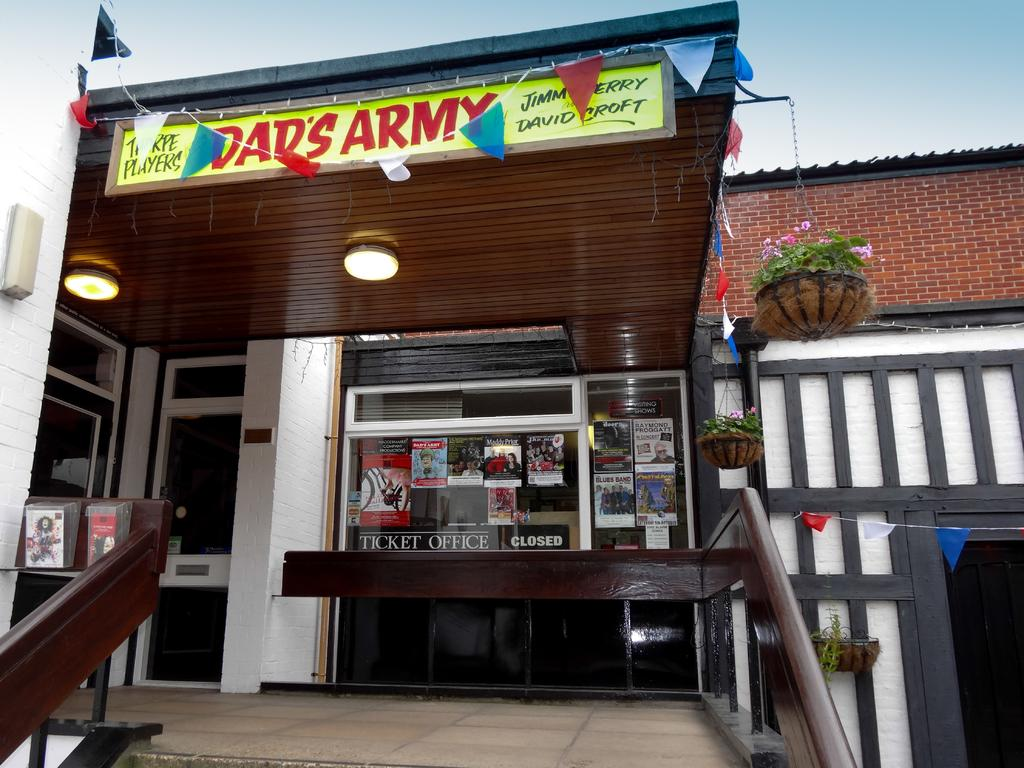<image>
Summarize the visual content of the image. Store fromt for Dad's Army that says "Ticket Office". 